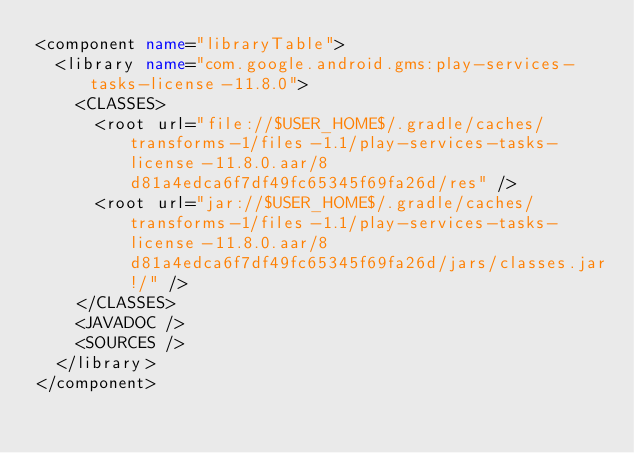Convert code to text. <code><loc_0><loc_0><loc_500><loc_500><_XML_><component name="libraryTable">
  <library name="com.google.android.gms:play-services-tasks-license-11.8.0">
    <CLASSES>
      <root url="file://$USER_HOME$/.gradle/caches/transforms-1/files-1.1/play-services-tasks-license-11.8.0.aar/8d81a4edca6f7df49fc65345f69fa26d/res" />
      <root url="jar://$USER_HOME$/.gradle/caches/transforms-1/files-1.1/play-services-tasks-license-11.8.0.aar/8d81a4edca6f7df49fc65345f69fa26d/jars/classes.jar!/" />
    </CLASSES>
    <JAVADOC />
    <SOURCES />
  </library>
</component></code> 